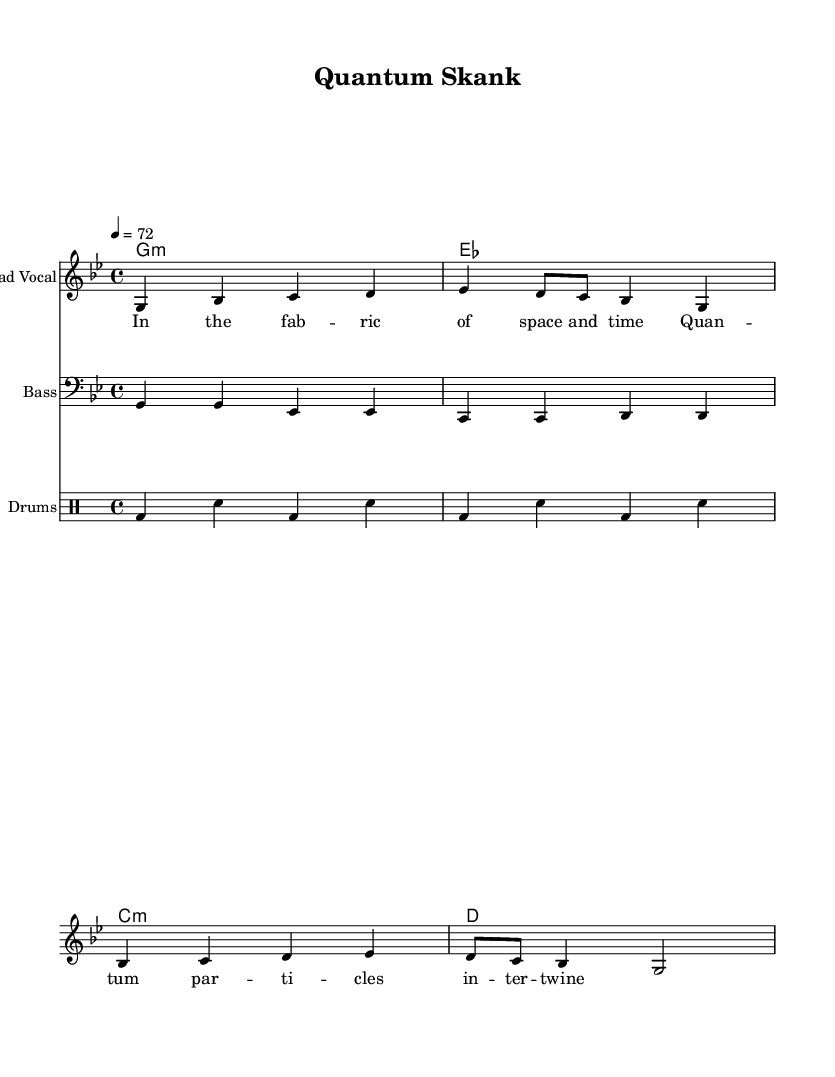What is the key signature of this music? The key signature is indicated by the sharps or flats at the beginning of the staff. In this piece, there are two flats (B flat and E flat), which signifies G minor.
Answer: G minor What is the time signature of this music? The time signature is represented as a fraction at the beginning of the staff. Here, it shows 4/4, meaning there are four beats in each measure and the quarter note gets one beat.
Answer: 4/4 What is the tempo marking of the song? The tempo is indicated at the top of the score by the number and note type. In this case, it states "4 = 72", which means there are 72 beats per minute.
Answer: 72 How many measures are there in the melody? To determine the number of measures, count the separate groups of notes divided by vertical lines (bar lines). There are eight measures in the melody section.
Answer: 8 What instrument is primarily featured in this piece? The instrument name is given at the beginning of the staff. In this case, it says "Lead Vocal," indicating that the vocals are the main feature of this composition.
Answer: Lead Vocal What type of chord progression is used in the guitar part? The type of chords can be identified by looking at the chord symbols provided. The chords are G minor, E flat, C minor, and D, indicating a common reggae chord progression.
Answer: G minor, E flat, C minor, D What musical genre is this piece categorized as? The title “Quantum Skank” along with the reggae rhythms and themes suggests it is rooted in reggae. Reggae is characterized by its offbeat rhythms and emphasis on the second and fourth beats.
Answer: Reggae 